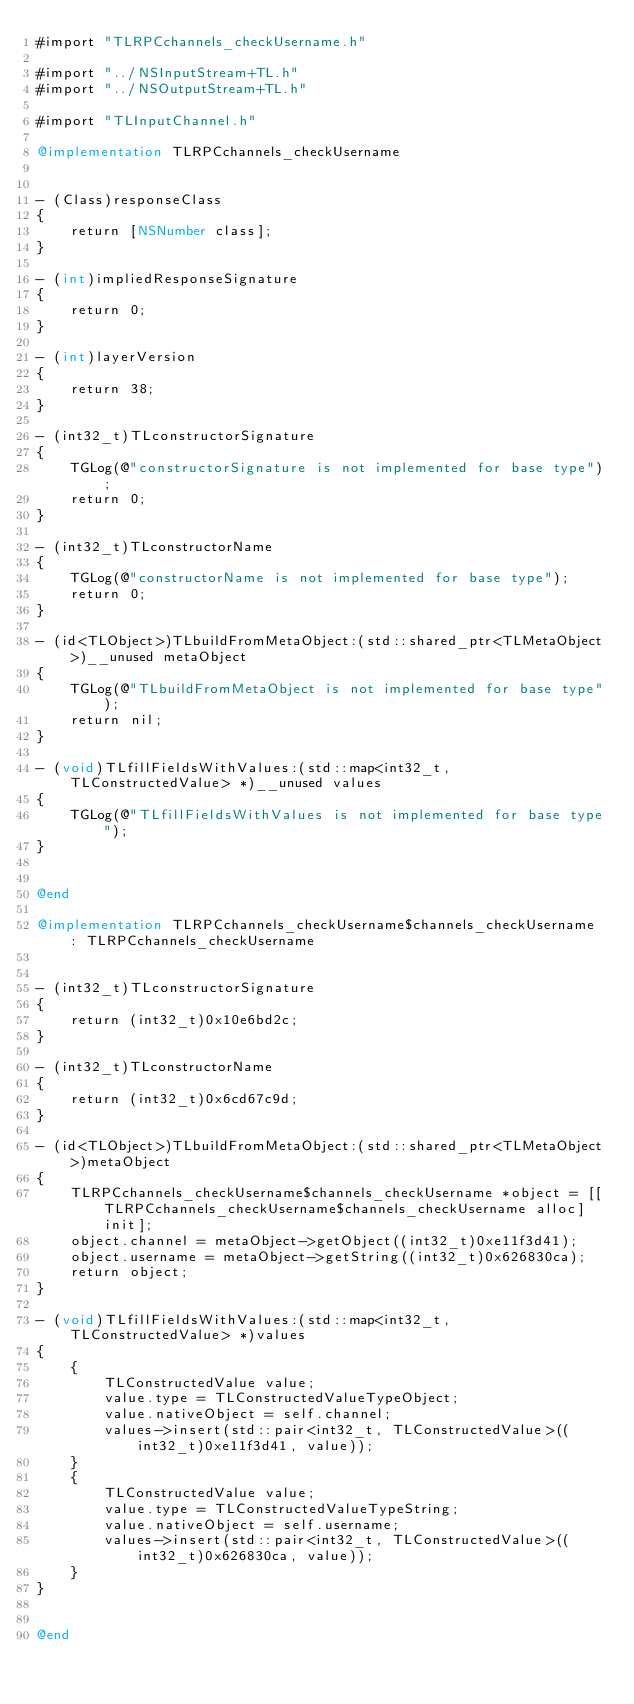Convert code to text. <code><loc_0><loc_0><loc_500><loc_500><_ObjectiveC_>#import "TLRPCchannels_checkUsername.h"

#import "../NSInputStream+TL.h"
#import "../NSOutputStream+TL.h"

#import "TLInputChannel.h"

@implementation TLRPCchannels_checkUsername


- (Class)responseClass
{
    return [NSNumber class];
}

- (int)impliedResponseSignature
{
    return 0;
}

- (int)layerVersion
{
    return 38;
}

- (int32_t)TLconstructorSignature
{
    TGLog(@"constructorSignature is not implemented for base type");
    return 0;
}

- (int32_t)TLconstructorName
{
    TGLog(@"constructorName is not implemented for base type");
    return 0;
}

- (id<TLObject>)TLbuildFromMetaObject:(std::shared_ptr<TLMetaObject>)__unused metaObject
{
    TGLog(@"TLbuildFromMetaObject is not implemented for base type");
    return nil;
}

- (void)TLfillFieldsWithValues:(std::map<int32_t, TLConstructedValue> *)__unused values
{
    TGLog(@"TLfillFieldsWithValues is not implemented for base type");
}


@end

@implementation TLRPCchannels_checkUsername$channels_checkUsername : TLRPCchannels_checkUsername


- (int32_t)TLconstructorSignature
{
    return (int32_t)0x10e6bd2c;
}

- (int32_t)TLconstructorName
{
    return (int32_t)0x6cd67c9d;
}

- (id<TLObject>)TLbuildFromMetaObject:(std::shared_ptr<TLMetaObject>)metaObject
{
    TLRPCchannels_checkUsername$channels_checkUsername *object = [[TLRPCchannels_checkUsername$channels_checkUsername alloc] init];
    object.channel = metaObject->getObject((int32_t)0xe11f3d41);
    object.username = metaObject->getString((int32_t)0x626830ca);
    return object;
}

- (void)TLfillFieldsWithValues:(std::map<int32_t, TLConstructedValue> *)values
{
    {
        TLConstructedValue value;
        value.type = TLConstructedValueTypeObject;
        value.nativeObject = self.channel;
        values->insert(std::pair<int32_t, TLConstructedValue>((int32_t)0xe11f3d41, value));
    }
    {
        TLConstructedValue value;
        value.type = TLConstructedValueTypeString;
        value.nativeObject = self.username;
        values->insert(std::pair<int32_t, TLConstructedValue>((int32_t)0x626830ca, value));
    }
}


@end

</code> 